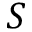Convert formula to latex. <formula><loc_0><loc_0><loc_500><loc_500>S</formula> 